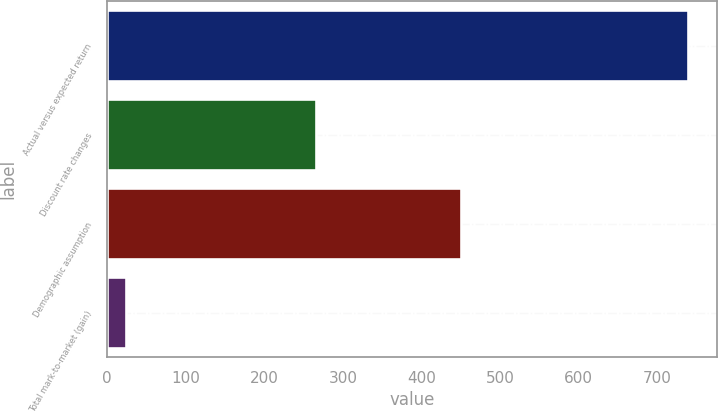<chart> <loc_0><loc_0><loc_500><loc_500><bar_chart><fcel>Actual versus expected return<fcel>Discount rate changes<fcel>Demographic assumption<fcel>Total mark-to-market (gain)<nl><fcel>740<fcel>266<fcel>450<fcel>24<nl></chart> 